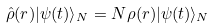<formula> <loc_0><loc_0><loc_500><loc_500>\hat { \rho } ( { r } ) | \psi ( t ) \rangle _ { N } = N \rho ( { r } ) | \psi ( t ) \rangle _ { N }</formula> 